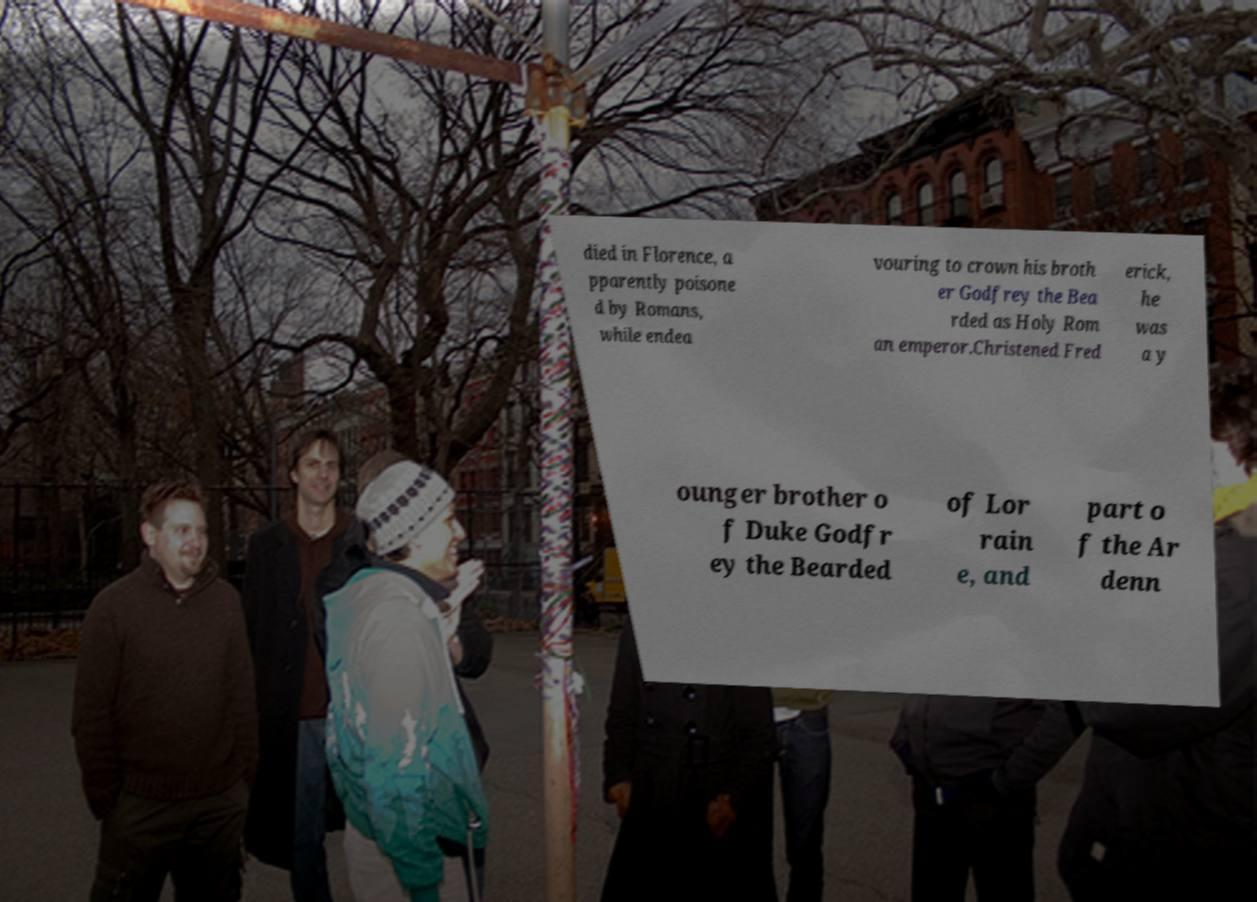What messages or text are displayed in this image? I need them in a readable, typed format. died in Florence, a pparently poisone d by Romans, while endea vouring to crown his broth er Godfrey the Bea rded as Holy Rom an emperor.Christened Fred erick, he was a y ounger brother o f Duke Godfr ey the Bearded of Lor rain e, and part o f the Ar denn 